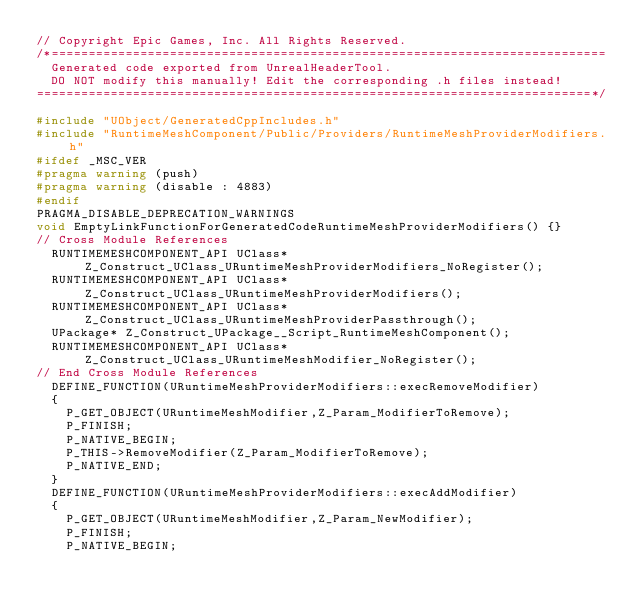<code> <loc_0><loc_0><loc_500><loc_500><_C++_>// Copyright Epic Games, Inc. All Rights Reserved.
/*===========================================================================
	Generated code exported from UnrealHeaderTool.
	DO NOT modify this manually! Edit the corresponding .h files instead!
===========================================================================*/

#include "UObject/GeneratedCppIncludes.h"
#include "RuntimeMeshComponent/Public/Providers/RuntimeMeshProviderModifiers.h"
#ifdef _MSC_VER
#pragma warning (push)
#pragma warning (disable : 4883)
#endif
PRAGMA_DISABLE_DEPRECATION_WARNINGS
void EmptyLinkFunctionForGeneratedCodeRuntimeMeshProviderModifiers() {}
// Cross Module References
	RUNTIMEMESHCOMPONENT_API UClass* Z_Construct_UClass_URuntimeMeshProviderModifiers_NoRegister();
	RUNTIMEMESHCOMPONENT_API UClass* Z_Construct_UClass_URuntimeMeshProviderModifiers();
	RUNTIMEMESHCOMPONENT_API UClass* Z_Construct_UClass_URuntimeMeshProviderPassthrough();
	UPackage* Z_Construct_UPackage__Script_RuntimeMeshComponent();
	RUNTIMEMESHCOMPONENT_API UClass* Z_Construct_UClass_URuntimeMeshModifier_NoRegister();
// End Cross Module References
	DEFINE_FUNCTION(URuntimeMeshProviderModifiers::execRemoveModifier)
	{
		P_GET_OBJECT(URuntimeMeshModifier,Z_Param_ModifierToRemove);
		P_FINISH;
		P_NATIVE_BEGIN;
		P_THIS->RemoveModifier(Z_Param_ModifierToRemove);
		P_NATIVE_END;
	}
	DEFINE_FUNCTION(URuntimeMeshProviderModifiers::execAddModifier)
	{
		P_GET_OBJECT(URuntimeMeshModifier,Z_Param_NewModifier);
		P_FINISH;
		P_NATIVE_BEGIN;</code> 